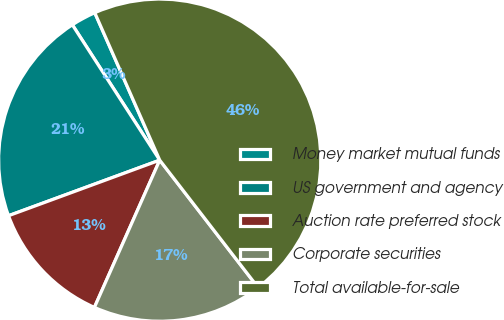<chart> <loc_0><loc_0><loc_500><loc_500><pie_chart><fcel>Money market mutual funds<fcel>US government and agency<fcel>Auction rate preferred stock<fcel>Corporate securities<fcel>Total available-for-sale<nl><fcel>2.52%<fcel>21.48%<fcel>12.75%<fcel>17.11%<fcel>46.14%<nl></chart> 